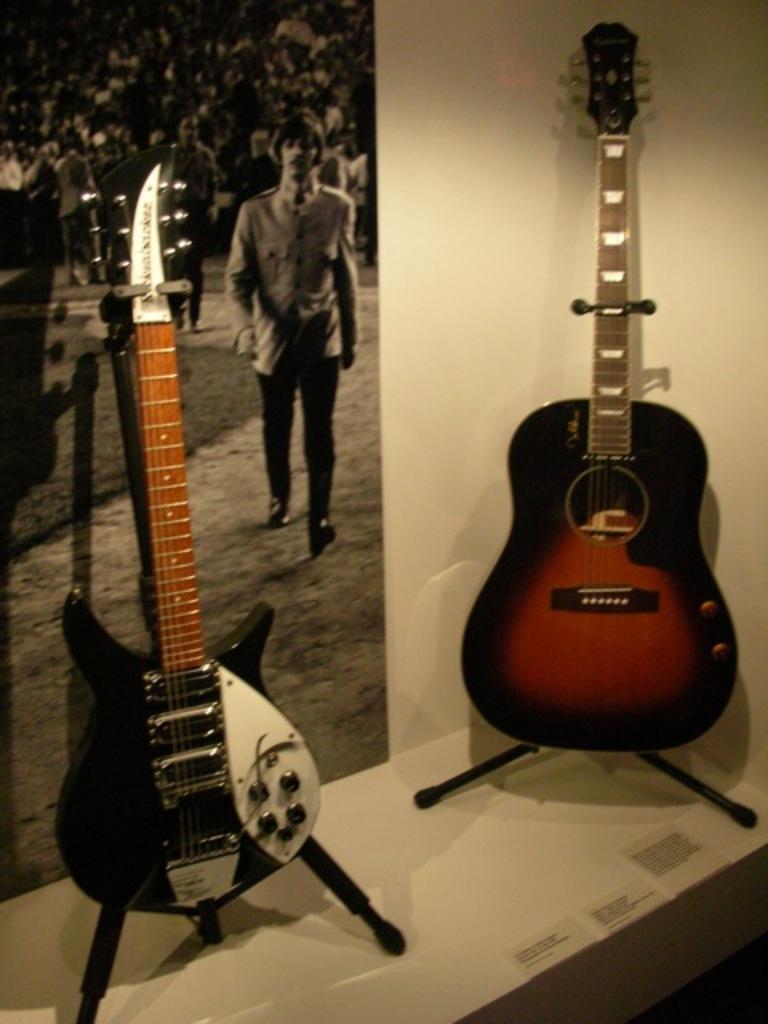Please provide a concise description of this image. Here there are two guitars,person walking,here the crowd is sitting. 